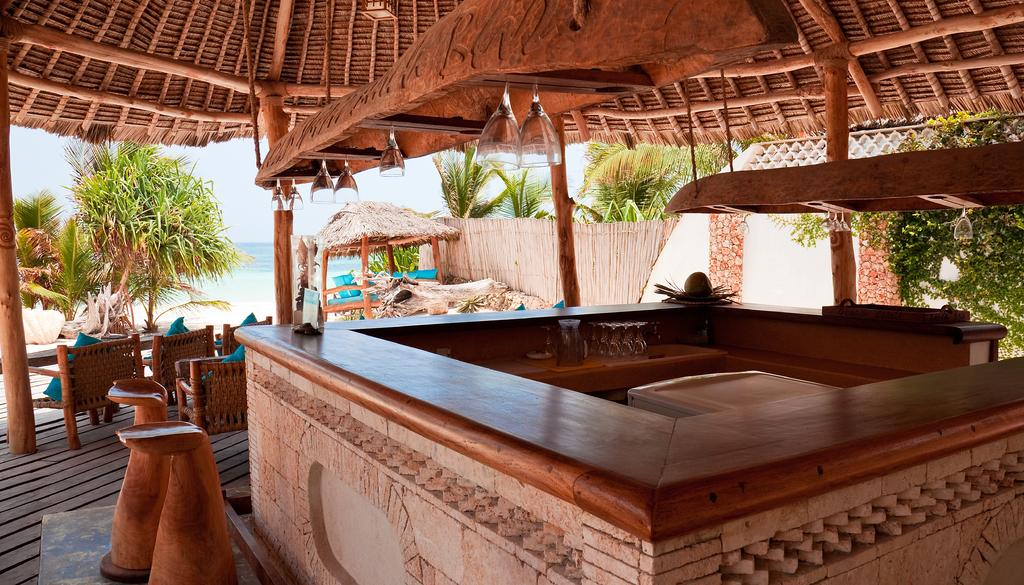What type of structures are in the image? There are huts in the image. What furniture is inside the huts? Chairs and tables are present inside the huts. What natural elements can be seen in the image? There are trees and water visible in the image. What type of education is being provided in the huts? There is no indication of education being provided in the image; it only shows huts with chairs and tables. How much profit is being generated from the huts in the image? There is no information about profit in the image; it only shows huts with chairs and tables. 